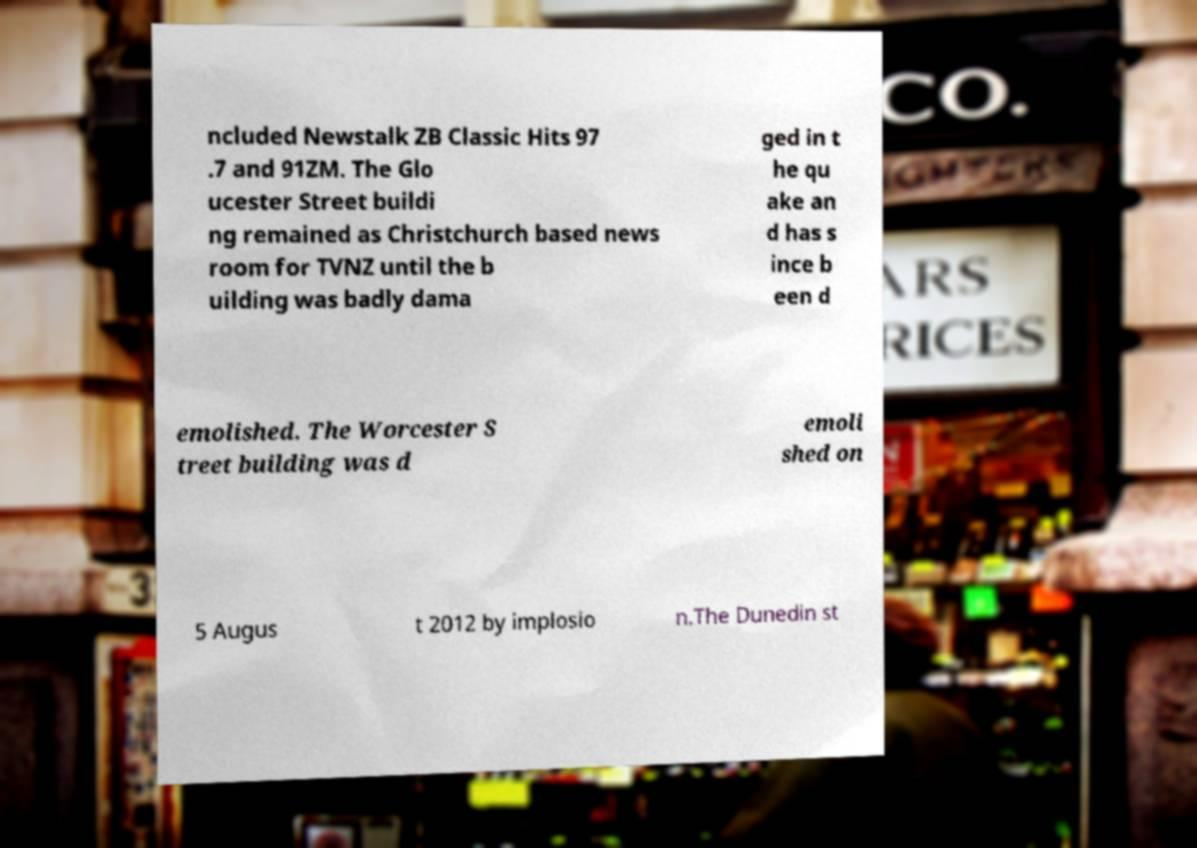Can you read and provide the text displayed in the image?This photo seems to have some interesting text. Can you extract and type it out for me? ncluded Newstalk ZB Classic Hits 97 .7 and 91ZM. The Glo ucester Street buildi ng remained as Christchurch based news room for TVNZ until the b uilding was badly dama ged in t he qu ake an d has s ince b een d emolished. The Worcester S treet building was d emoli shed on 5 Augus t 2012 by implosio n.The Dunedin st 